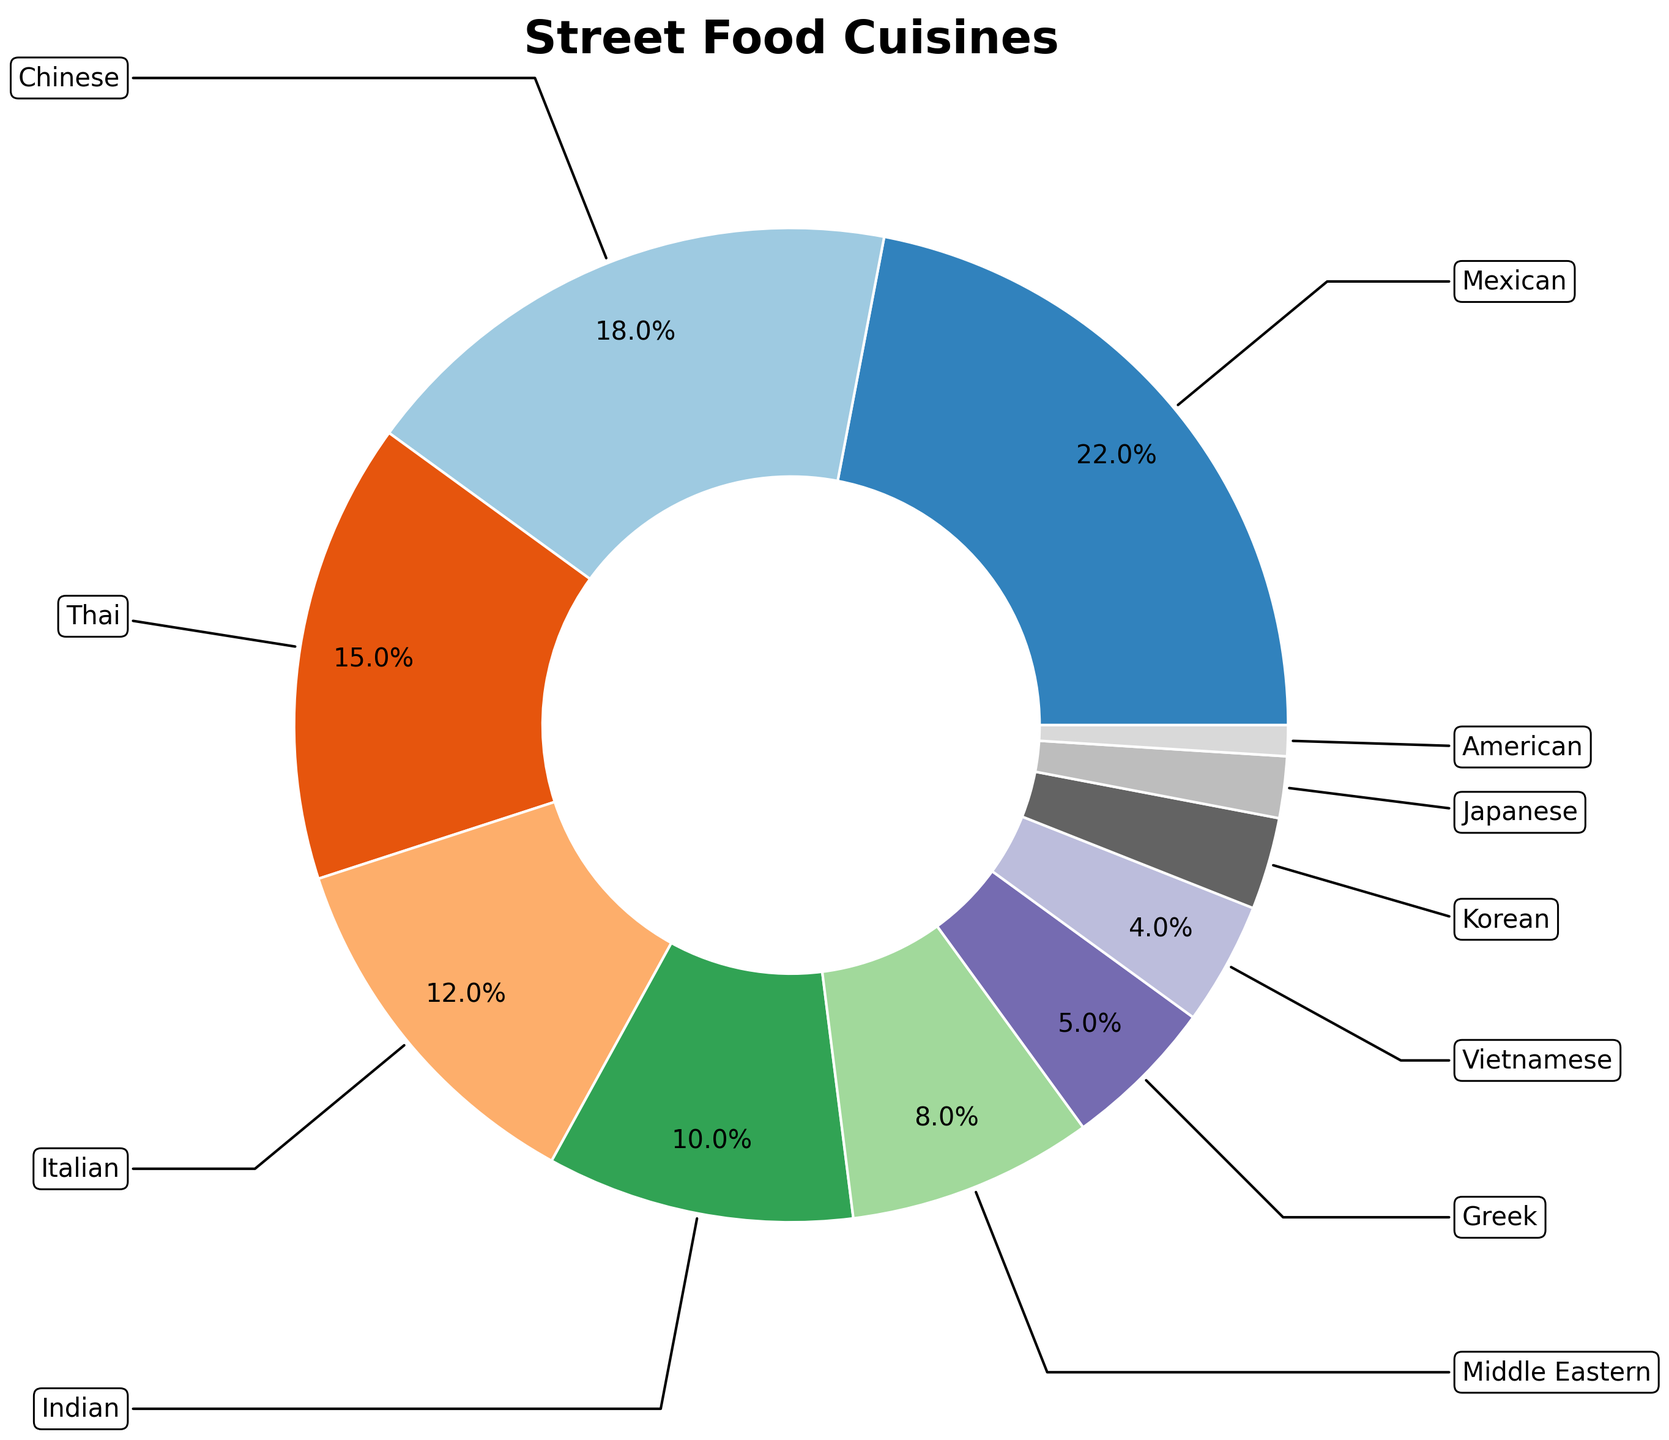What's the most represented cuisine in the city's street food scene? By looking at the largest slice in the pie chart, we can see which cuisine has the highest percentage. The Mexican cuisine represents the largest proportion.
Answer: Mexican Which two cuisines have a combined proportion of exactly 30%? By identifying and adding the percentages of different cuisines, we find that Italian (12%) and Indian (10%) together make 22%, not 30%, and Chinese (18%) along with Thai (15%) make 33%. The accurate combination is Middle Eastern (8%) and Greek (5%), which also make less. Thus, it's Thai (15%) plus Greek (5%).
Answer: Thai, Greek How much more percentage does Mexican cuisine have compared to Japanese cuisine? To find the difference, we subtract the percentage of Japanese cuisine (2%) from Mexican cuisine (22%). So, the difference is 22% - 2% = 20%.
Answer: 20% What's the total percentage contributed by Asian cuisines (Chinese, Thai, Indian, Vietnamese, Korean, Japanese)? Adding up the percentages of these cuisines: Chinese (18%) + Thai (15%) + Indian (10%) + Vietnamese (4%) + Korean (3%) + Japanese (2%) = 52%.
Answer: 52% Is the percentage of Middle Eastern cuisine greater than or equal to that of Greek cuisine? By comparing the percentages, Middle Eastern cuisine (8%) is greater than Greek cuisine (5%).
Answer: Yes How many cuisines contribute less than 5% each? By looking at the slices of the pie chart that represent less than 5%, we identify Vietnamese (4%), Korean (3%), Japanese (2%), and American (1%). There are 4 such cuisines.
Answer: 4 What's the difference in percentage between the most and the least represented cuisines? The most represented cuisine is Mexican with 22%, and the least represented is American with 1%. The difference is 22% - 1% = 21%.
Answer: 21% What percentage of the street food scene is made up of cuisines from the Americas (both North and South)? Adding the percentages for Mexican (22%) and American (1%), the total is 22% + 1% = 23%.
Answer: 23% Comparing Greek and Vietnamese cuisines, which one has a smaller proportion? By comparing the percentages directly, Greek (5%) has a larger proportion than Vietnamese (4%).
Answer: Vietnamese What's the combined total percentage for the cuisines representing less than 10% each? Adding the percentages for all the cuisines that have less than 10%: Middle Eastern (8%) + Greek (5%) + Vietnamese (4%) + Korean (3%) + Japanese (2%) + American (1%) = 23%.
Answer: 23% 